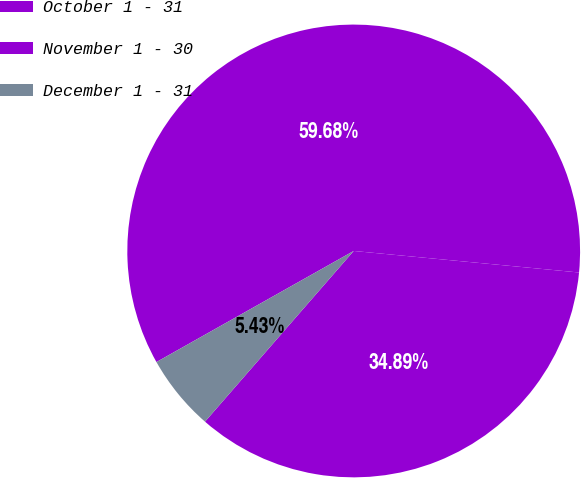Convert chart. <chart><loc_0><loc_0><loc_500><loc_500><pie_chart><fcel>October 1 - 31<fcel>November 1 - 30<fcel>December 1 - 31<nl><fcel>34.89%<fcel>59.68%<fcel>5.43%<nl></chart> 